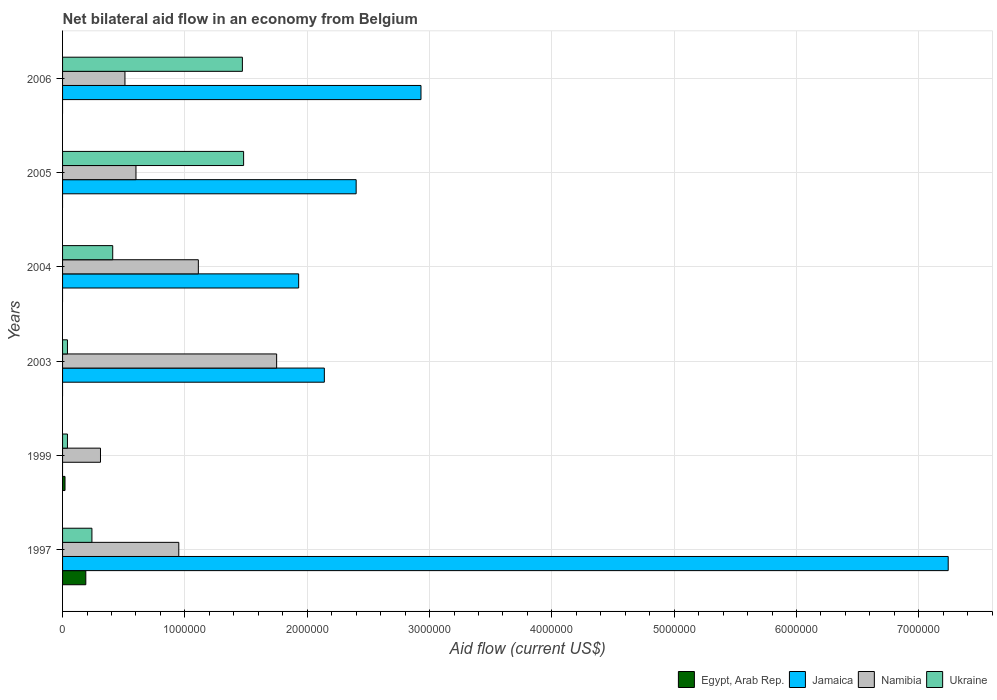How many different coloured bars are there?
Give a very brief answer. 4. Are the number of bars per tick equal to the number of legend labels?
Keep it short and to the point. No. Are the number of bars on each tick of the Y-axis equal?
Your response must be concise. No. What is the label of the 3rd group of bars from the top?
Provide a succinct answer. 2004. What is the net bilateral aid flow in Jamaica in 2005?
Make the answer very short. 2.40e+06. Across all years, what is the maximum net bilateral aid flow in Jamaica?
Your response must be concise. 7.24e+06. Across all years, what is the minimum net bilateral aid flow in Ukraine?
Offer a very short reply. 4.00e+04. In which year was the net bilateral aid flow in Jamaica maximum?
Make the answer very short. 1997. What is the total net bilateral aid flow in Egypt, Arab Rep. in the graph?
Offer a very short reply. 2.10e+05. What is the difference between the net bilateral aid flow in Jamaica in 2006 and the net bilateral aid flow in Egypt, Arab Rep. in 1997?
Your answer should be compact. 2.74e+06. What is the average net bilateral aid flow in Egypt, Arab Rep. per year?
Give a very brief answer. 3.50e+04. In the year 2005, what is the difference between the net bilateral aid flow in Namibia and net bilateral aid flow in Jamaica?
Your answer should be compact. -1.80e+06. In how many years, is the net bilateral aid flow in Namibia greater than 6200000 US$?
Your answer should be compact. 0. What is the ratio of the net bilateral aid flow in Ukraine in 2003 to that in 2006?
Make the answer very short. 0.03. Is the difference between the net bilateral aid flow in Namibia in 2003 and 2004 greater than the difference between the net bilateral aid flow in Jamaica in 2003 and 2004?
Keep it short and to the point. Yes. What is the difference between the highest and the second highest net bilateral aid flow in Ukraine?
Offer a terse response. 10000. What is the difference between the highest and the lowest net bilateral aid flow in Namibia?
Keep it short and to the point. 1.44e+06. Is the sum of the net bilateral aid flow in Jamaica in 2003 and 2004 greater than the maximum net bilateral aid flow in Egypt, Arab Rep. across all years?
Your answer should be very brief. Yes. Is it the case that in every year, the sum of the net bilateral aid flow in Namibia and net bilateral aid flow in Jamaica is greater than the sum of net bilateral aid flow in Egypt, Arab Rep. and net bilateral aid flow in Ukraine?
Your answer should be very brief. No. Are all the bars in the graph horizontal?
Your answer should be compact. Yes. What is the difference between two consecutive major ticks on the X-axis?
Offer a very short reply. 1.00e+06. Does the graph contain any zero values?
Give a very brief answer. Yes. Where does the legend appear in the graph?
Your answer should be compact. Bottom right. How many legend labels are there?
Provide a succinct answer. 4. What is the title of the graph?
Ensure brevity in your answer.  Net bilateral aid flow in an economy from Belgium. What is the label or title of the Y-axis?
Your response must be concise. Years. What is the Aid flow (current US$) of Egypt, Arab Rep. in 1997?
Your answer should be very brief. 1.90e+05. What is the Aid flow (current US$) of Jamaica in 1997?
Keep it short and to the point. 7.24e+06. What is the Aid flow (current US$) of Namibia in 1997?
Offer a terse response. 9.50e+05. What is the Aid flow (current US$) in Egypt, Arab Rep. in 1999?
Ensure brevity in your answer.  2.00e+04. What is the Aid flow (current US$) of Jamaica in 1999?
Make the answer very short. 0. What is the Aid flow (current US$) of Ukraine in 1999?
Offer a very short reply. 4.00e+04. What is the Aid flow (current US$) of Egypt, Arab Rep. in 2003?
Your answer should be compact. 0. What is the Aid flow (current US$) of Jamaica in 2003?
Offer a terse response. 2.14e+06. What is the Aid flow (current US$) in Namibia in 2003?
Make the answer very short. 1.75e+06. What is the Aid flow (current US$) of Ukraine in 2003?
Offer a terse response. 4.00e+04. What is the Aid flow (current US$) of Egypt, Arab Rep. in 2004?
Your answer should be compact. 0. What is the Aid flow (current US$) of Jamaica in 2004?
Your response must be concise. 1.93e+06. What is the Aid flow (current US$) in Namibia in 2004?
Your response must be concise. 1.11e+06. What is the Aid flow (current US$) of Jamaica in 2005?
Keep it short and to the point. 2.40e+06. What is the Aid flow (current US$) of Ukraine in 2005?
Your response must be concise. 1.48e+06. What is the Aid flow (current US$) in Egypt, Arab Rep. in 2006?
Your answer should be very brief. 0. What is the Aid flow (current US$) in Jamaica in 2006?
Give a very brief answer. 2.93e+06. What is the Aid flow (current US$) in Namibia in 2006?
Give a very brief answer. 5.10e+05. What is the Aid flow (current US$) in Ukraine in 2006?
Ensure brevity in your answer.  1.47e+06. Across all years, what is the maximum Aid flow (current US$) in Jamaica?
Offer a very short reply. 7.24e+06. Across all years, what is the maximum Aid flow (current US$) in Namibia?
Offer a very short reply. 1.75e+06. Across all years, what is the maximum Aid flow (current US$) of Ukraine?
Provide a short and direct response. 1.48e+06. Across all years, what is the minimum Aid flow (current US$) in Namibia?
Keep it short and to the point. 3.10e+05. What is the total Aid flow (current US$) in Jamaica in the graph?
Your answer should be very brief. 1.66e+07. What is the total Aid flow (current US$) in Namibia in the graph?
Your answer should be very brief. 5.23e+06. What is the total Aid flow (current US$) of Ukraine in the graph?
Offer a terse response. 3.68e+06. What is the difference between the Aid flow (current US$) in Namibia in 1997 and that in 1999?
Provide a succinct answer. 6.40e+05. What is the difference between the Aid flow (current US$) of Jamaica in 1997 and that in 2003?
Your response must be concise. 5.10e+06. What is the difference between the Aid flow (current US$) of Namibia in 1997 and that in 2003?
Keep it short and to the point. -8.00e+05. What is the difference between the Aid flow (current US$) in Jamaica in 1997 and that in 2004?
Provide a succinct answer. 5.31e+06. What is the difference between the Aid flow (current US$) in Namibia in 1997 and that in 2004?
Keep it short and to the point. -1.60e+05. What is the difference between the Aid flow (current US$) in Jamaica in 1997 and that in 2005?
Provide a succinct answer. 4.84e+06. What is the difference between the Aid flow (current US$) in Ukraine in 1997 and that in 2005?
Provide a short and direct response. -1.24e+06. What is the difference between the Aid flow (current US$) in Jamaica in 1997 and that in 2006?
Your response must be concise. 4.31e+06. What is the difference between the Aid flow (current US$) of Namibia in 1997 and that in 2006?
Ensure brevity in your answer.  4.40e+05. What is the difference between the Aid flow (current US$) of Ukraine in 1997 and that in 2006?
Your answer should be very brief. -1.23e+06. What is the difference between the Aid flow (current US$) of Namibia in 1999 and that in 2003?
Ensure brevity in your answer.  -1.44e+06. What is the difference between the Aid flow (current US$) of Namibia in 1999 and that in 2004?
Make the answer very short. -8.00e+05. What is the difference between the Aid flow (current US$) of Ukraine in 1999 and that in 2004?
Ensure brevity in your answer.  -3.70e+05. What is the difference between the Aid flow (current US$) in Namibia in 1999 and that in 2005?
Offer a very short reply. -2.90e+05. What is the difference between the Aid flow (current US$) in Ukraine in 1999 and that in 2005?
Keep it short and to the point. -1.44e+06. What is the difference between the Aid flow (current US$) in Namibia in 1999 and that in 2006?
Provide a succinct answer. -2.00e+05. What is the difference between the Aid flow (current US$) in Ukraine in 1999 and that in 2006?
Provide a short and direct response. -1.43e+06. What is the difference between the Aid flow (current US$) in Namibia in 2003 and that in 2004?
Your answer should be very brief. 6.40e+05. What is the difference between the Aid flow (current US$) in Ukraine in 2003 and that in 2004?
Provide a succinct answer. -3.70e+05. What is the difference between the Aid flow (current US$) of Namibia in 2003 and that in 2005?
Offer a terse response. 1.15e+06. What is the difference between the Aid flow (current US$) in Ukraine in 2003 and that in 2005?
Keep it short and to the point. -1.44e+06. What is the difference between the Aid flow (current US$) of Jamaica in 2003 and that in 2006?
Keep it short and to the point. -7.90e+05. What is the difference between the Aid flow (current US$) of Namibia in 2003 and that in 2006?
Your answer should be very brief. 1.24e+06. What is the difference between the Aid flow (current US$) of Ukraine in 2003 and that in 2006?
Your answer should be very brief. -1.43e+06. What is the difference between the Aid flow (current US$) in Jamaica in 2004 and that in 2005?
Keep it short and to the point. -4.70e+05. What is the difference between the Aid flow (current US$) in Namibia in 2004 and that in 2005?
Keep it short and to the point. 5.10e+05. What is the difference between the Aid flow (current US$) in Ukraine in 2004 and that in 2005?
Ensure brevity in your answer.  -1.07e+06. What is the difference between the Aid flow (current US$) of Ukraine in 2004 and that in 2006?
Offer a terse response. -1.06e+06. What is the difference between the Aid flow (current US$) of Jamaica in 2005 and that in 2006?
Your answer should be compact. -5.30e+05. What is the difference between the Aid flow (current US$) of Ukraine in 2005 and that in 2006?
Keep it short and to the point. 10000. What is the difference between the Aid flow (current US$) of Egypt, Arab Rep. in 1997 and the Aid flow (current US$) of Namibia in 1999?
Your answer should be very brief. -1.20e+05. What is the difference between the Aid flow (current US$) of Egypt, Arab Rep. in 1997 and the Aid flow (current US$) of Ukraine in 1999?
Offer a terse response. 1.50e+05. What is the difference between the Aid flow (current US$) in Jamaica in 1997 and the Aid flow (current US$) in Namibia in 1999?
Give a very brief answer. 6.93e+06. What is the difference between the Aid flow (current US$) in Jamaica in 1997 and the Aid flow (current US$) in Ukraine in 1999?
Provide a succinct answer. 7.20e+06. What is the difference between the Aid flow (current US$) of Namibia in 1997 and the Aid flow (current US$) of Ukraine in 1999?
Ensure brevity in your answer.  9.10e+05. What is the difference between the Aid flow (current US$) of Egypt, Arab Rep. in 1997 and the Aid flow (current US$) of Jamaica in 2003?
Offer a very short reply. -1.95e+06. What is the difference between the Aid flow (current US$) in Egypt, Arab Rep. in 1997 and the Aid flow (current US$) in Namibia in 2003?
Provide a short and direct response. -1.56e+06. What is the difference between the Aid flow (current US$) of Egypt, Arab Rep. in 1997 and the Aid flow (current US$) of Ukraine in 2003?
Offer a terse response. 1.50e+05. What is the difference between the Aid flow (current US$) in Jamaica in 1997 and the Aid flow (current US$) in Namibia in 2003?
Provide a succinct answer. 5.49e+06. What is the difference between the Aid flow (current US$) in Jamaica in 1997 and the Aid flow (current US$) in Ukraine in 2003?
Your response must be concise. 7.20e+06. What is the difference between the Aid flow (current US$) in Namibia in 1997 and the Aid flow (current US$) in Ukraine in 2003?
Keep it short and to the point. 9.10e+05. What is the difference between the Aid flow (current US$) of Egypt, Arab Rep. in 1997 and the Aid flow (current US$) of Jamaica in 2004?
Keep it short and to the point. -1.74e+06. What is the difference between the Aid flow (current US$) of Egypt, Arab Rep. in 1997 and the Aid flow (current US$) of Namibia in 2004?
Your answer should be compact. -9.20e+05. What is the difference between the Aid flow (current US$) in Jamaica in 1997 and the Aid flow (current US$) in Namibia in 2004?
Give a very brief answer. 6.13e+06. What is the difference between the Aid flow (current US$) of Jamaica in 1997 and the Aid flow (current US$) of Ukraine in 2004?
Your response must be concise. 6.83e+06. What is the difference between the Aid flow (current US$) in Namibia in 1997 and the Aid flow (current US$) in Ukraine in 2004?
Offer a very short reply. 5.40e+05. What is the difference between the Aid flow (current US$) of Egypt, Arab Rep. in 1997 and the Aid flow (current US$) of Jamaica in 2005?
Your response must be concise. -2.21e+06. What is the difference between the Aid flow (current US$) of Egypt, Arab Rep. in 1997 and the Aid flow (current US$) of Namibia in 2005?
Offer a terse response. -4.10e+05. What is the difference between the Aid flow (current US$) in Egypt, Arab Rep. in 1997 and the Aid flow (current US$) in Ukraine in 2005?
Your response must be concise. -1.29e+06. What is the difference between the Aid flow (current US$) of Jamaica in 1997 and the Aid flow (current US$) of Namibia in 2005?
Ensure brevity in your answer.  6.64e+06. What is the difference between the Aid flow (current US$) in Jamaica in 1997 and the Aid flow (current US$) in Ukraine in 2005?
Make the answer very short. 5.76e+06. What is the difference between the Aid flow (current US$) in Namibia in 1997 and the Aid flow (current US$) in Ukraine in 2005?
Your answer should be very brief. -5.30e+05. What is the difference between the Aid flow (current US$) in Egypt, Arab Rep. in 1997 and the Aid flow (current US$) in Jamaica in 2006?
Make the answer very short. -2.74e+06. What is the difference between the Aid flow (current US$) in Egypt, Arab Rep. in 1997 and the Aid flow (current US$) in Namibia in 2006?
Keep it short and to the point. -3.20e+05. What is the difference between the Aid flow (current US$) in Egypt, Arab Rep. in 1997 and the Aid flow (current US$) in Ukraine in 2006?
Give a very brief answer. -1.28e+06. What is the difference between the Aid flow (current US$) in Jamaica in 1997 and the Aid flow (current US$) in Namibia in 2006?
Offer a very short reply. 6.73e+06. What is the difference between the Aid flow (current US$) in Jamaica in 1997 and the Aid flow (current US$) in Ukraine in 2006?
Provide a succinct answer. 5.77e+06. What is the difference between the Aid flow (current US$) of Namibia in 1997 and the Aid flow (current US$) of Ukraine in 2006?
Your answer should be very brief. -5.20e+05. What is the difference between the Aid flow (current US$) of Egypt, Arab Rep. in 1999 and the Aid flow (current US$) of Jamaica in 2003?
Give a very brief answer. -2.12e+06. What is the difference between the Aid flow (current US$) of Egypt, Arab Rep. in 1999 and the Aid flow (current US$) of Namibia in 2003?
Give a very brief answer. -1.73e+06. What is the difference between the Aid flow (current US$) of Namibia in 1999 and the Aid flow (current US$) of Ukraine in 2003?
Provide a succinct answer. 2.70e+05. What is the difference between the Aid flow (current US$) in Egypt, Arab Rep. in 1999 and the Aid flow (current US$) in Jamaica in 2004?
Your answer should be very brief. -1.91e+06. What is the difference between the Aid flow (current US$) of Egypt, Arab Rep. in 1999 and the Aid flow (current US$) of Namibia in 2004?
Ensure brevity in your answer.  -1.09e+06. What is the difference between the Aid flow (current US$) of Egypt, Arab Rep. in 1999 and the Aid flow (current US$) of Ukraine in 2004?
Your answer should be very brief. -3.90e+05. What is the difference between the Aid flow (current US$) in Egypt, Arab Rep. in 1999 and the Aid flow (current US$) in Jamaica in 2005?
Offer a very short reply. -2.38e+06. What is the difference between the Aid flow (current US$) of Egypt, Arab Rep. in 1999 and the Aid flow (current US$) of Namibia in 2005?
Your response must be concise. -5.80e+05. What is the difference between the Aid flow (current US$) of Egypt, Arab Rep. in 1999 and the Aid flow (current US$) of Ukraine in 2005?
Your answer should be compact. -1.46e+06. What is the difference between the Aid flow (current US$) of Namibia in 1999 and the Aid flow (current US$) of Ukraine in 2005?
Make the answer very short. -1.17e+06. What is the difference between the Aid flow (current US$) in Egypt, Arab Rep. in 1999 and the Aid flow (current US$) in Jamaica in 2006?
Offer a terse response. -2.91e+06. What is the difference between the Aid flow (current US$) in Egypt, Arab Rep. in 1999 and the Aid flow (current US$) in Namibia in 2006?
Provide a succinct answer. -4.90e+05. What is the difference between the Aid flow (current US$) of Egypt, Arab Rep. in 1999 and the Aid flow (current US$) of Ukraine in 2006?
Your answer should be compact. -1.45e+06. What is the difference between the Aid flow (current US$) of Namibia in 1999 and the Aid flow (current US$) of Ukraine in 2006?
Your response must be concise. -1.16e+06. What is the difference between the Aid flow (current US$) of Jamaica in 2003 and the Aid flow (current US$) of Namibia in 2004?
Keep it short and to the point. 1.03e+06. What is the difference between the Aid flow (current US$) of Jamaica in 2003 and the Aid flow (current US$) of Ukraine in 2004?
Offer a terse response. 1.73e+06. What is the difference between the Aid flow (current US$) of Namibia in 2003 and the Aid flow (current US$) of Ukraine in 2004?
Provide a succinct answer. 1.34e+06. What is the difference between the Aid flow (current US$) in Jamaica in 2003 and the Aid flow (current US$) in Namibia in 2005?
Make the answer very short. 1.54e+06. What is the difference between the Aid flow (current US$) of Namibia in 2003 and the Aid flow (current US$) of Ukraine in 2005?
Your answer should be compact. 2.70e+05. What is the difference between the Aid flow (current US$) in Jamaica in 2003 and the Aid flow (current US$) in Namibia in 2006?
Offer a very short reply. 1.63e+06. What is the difference between the Aid flow (current US$) in Jamaica in 2003 and the Aid flow (current US$) in Ukraine in 2006?
Keep it short and to the point. 6.70e+05. What is the difference between the Aid flow (current US$) of Namibia in 2003 and the Aid flow (current US$) of Ukraine in 2006?
Your answer should be very brief. 2.80e+05. What is the difference between the Aid flow (current US$) in Jamaica in 2004 and the Aid flow (current US$) in Namibia in 2005?
Provide a short and direct response. 1.33e+06. What is the difference between the Aid flow (current US$) of Namibia in 2004 and the Aid flow (current US$) of Ukraine in 2005?
Give a very brief answer. -3.70e+05. What is the difference between the Aid flow (current US$) in Jamaica in 2004 and the Aid flow (current US$) in Namibia in 2006?
Give a very brief answer. 1.42e+06. What is the difference between the Aid flow (current US$) in Namibia in 2004 and the Aid flow (current US$) in Ukraine in 2006?
Your answer should be compact. -3.60e+05. What is the difference between the Aid flow (current US$) of Jamaica in 2005 and the Aid flow (current US$) of Namibia in 2006?
Ensure brevity in your answer.  1.89e+06. What is the difference between the Aid flow (current US$) of Jamaica in 2005 and the Aid flow (current US$) of Ukraine in 2006?
Offer a very short reply. 9.30e+05. What is the difference between the Aid flow (current US$) in Namibia in 2005 and the Aid flow (current US$) in Ukraine in 2006?
Your answer should be very brief. -8.70e+05. What is the average Aid flow (current US$) of Egypt, Arab Rep. per year?
Keep it short and to the point. 3.50e+04. What is the average Aid flow (current US$) in Jamaica per year?
Provide a short and direct response. 2.77e+06. What is the average Aid flow (current US$) in Namibia per year?
Ensure brevity in your answer.  8.72e+05. What is the average Aid flow (current US$) of Ukraine per year?
Provide a succinct answer. 6.13e+05. In the year 1997, what is the difference between the Aid flow (current US$) in Egypt, Arab Rep. and Aid flow (current US$) in Jamaica?
Offer a very short reply. -7.05e+06. In the year 1997, what is the difference between the Aid flow (current US$) in Egypt, Arab Rep. and Aid flow (current US$) in Namibia?
Give a very brief answer. -7.60e+05. In the year 1997, what is the difference between the Aid flow (current US$) in Jamaica and Aid flow (current US$) in Namibia?
Make the answer very short. 6.29e+06. In the year 1997, what is the difference between the Aid flow (current US$) of Namibia and Aid flow (current US$) of Ukraine?
Make the answer very short. 7.10e+05. In the year 1999, what is the difference between the Aid flow (current US$) of Namibia and Aid flow (current US$) of Ukraine?
Offer a very short reply. 2.70e+05. In the year 2003, what is the difference between the Aid flow (current US$) of Jamaica and Aid flow (current US$) of Namibia?
Make the answer very short. 3.90e+05. In the year 2003, what is the difference between the Aid flow (current US$) of Jamaica and Aid flow (current US$) of Ukraine?
Offer a terse response. 2.10e+06. In the year 2003, what is the difference between the Aid flow (current US$) in Namibia and Aid flow (current US$) in Ukraine?
Provide a succinct answer. 1.71e+06. In the year 2004, what is the difference between the Aid flow (current US$) in Jamaica and Aid flow (current US$) in Namibia?
Provide a short and direct response. 8.20e+05. In the year 2004, what is the difference between the Aid flow (current US$) in Jamaica and Aid flow (current US$) in Ukraine?
Provide a succinct answer. 1.52e+06. In the year 2004, what is the difference between the Aid flow (current US$) in Namibia and Aid flow (current US$) in Ukraine?
Ensure brevity in your answer.  7.00e+05. In the year 2005, what is the difference between the Aid flow (current US$) of Jamaica and Aid flow (current US$) of Namibia?
Offer a terse response. 1.80e+06. In the year 2005, what is the difference between the Aid flow (current US$) in Jamaica and Aid flow (current US$) in Ukraine?
Your answer should be very brief. 9.20e+05. In the year 2005, what is the difference between the Aid flow (current US$) of Namibia and Aid flow (current US$) of Ukraine?
Your response must be concise. -8.80e+05. In the year 2006, what is the difference between the Aid flow (current US$) of Jamaica and Aid flow (current US$) of Namibia?
Give a very brief answer. 2.42e+06. In the year 2006, what is the difference between the Aid flow (current US$) of Jamaica and Aid flow (current US$) of Ukraine?
Make the answer very short. 1.46e+06. In the year 2006, what is the difference between the Aid flow (current US$) in Namibia and Aid flow (current US$) in Ukraine?
Your answer should be very brief. -9.60e+05. What is the ratio of the Aid flow (current US$) in Egypt, Arab Rep. in 1997 to that in 1999?
Provide a short and direct response. 9.5. What is the ratio of the Aid flow (current US$) in Namibia in 1997 to that in 1999?
Give a very brief answer. 3.06. What is the ratio of the Aid flow (current US$) of Jamaica in 1997 to that in 2003?
Your answer should be very brief. 3.38. What is the ratio of the Aid flow (current US$) in Namibia in 1997 to that in 2003?
Make the answer very short. 0.54. What is the ratio of the Aid flow (current US$) in Ukraine in 1997 to that in 2003?
Offer a very short reply. 6. What is the ratio of the Aid flow (current US$) in Jamaica in 1997 to that in 2004?
Provide a succinct answer. 3.75. What is the ratio of the Aid flow (current US$) in Namibia in 1997 to that in 2004?
Ensure brevity in your answer.  0.86. What is the ratio of the Aid flow (current US$) of Ukraine in 1997 to that in 2004?
Your answer should be compact. 0.59. What is the ratio of the Aid flow (current US$) in Jamaica in 1997 to that in 2005?
Keep it short and to the point. 3.02. What is the ratio of the Aid flow (current US$) of Namibia in 1997 to that in 2005?
Offer a terse response. 1.58. What is the ratio of the Aid flow (current US$) in Ukraine in 1997 to that in 2005?
Keep it short and to the point. 0.16. What is the ratio of the Aid flow (current US$) of Jamaica in 1997 to that in 2006?
Offer a very short reply. 2.47. What is the ratio of the Aid flow (current US$) in Namibia in 1997 to that in 2006?
Provide a short and direct response. 1.86. What is the ratio of the Aid flow (current US$) in Ukraine in 1997 to that in 2006?
Offer a terse response. 0.16. What is the ratio of the Aid flow (current US$) of Namibia in 1999 to that in 2003?
Offer a very short reply. 0.18. What is the ratio of the Aid flow (current US$) of Ukraine in 1999 to that in 2003?
Provide a short and direct response. 1. What is the ratio of the Aid flow (current US$) of Namibia in 1999 to that in 2004?
Keep it short and to the point. 0.28. What is the ratio of the Aid flow (current US$) in Ukraine in 1999 to that in 2004?
Your answer should be very brief. 0.1. What is the ratio of the Aid flow (current US$) of Namibia in 1999 to that in 2005?
Make the answer very short. 0.52. What is the ratio of the Aid flow (current US$) of Ukraine in 1999 to that in 2005?
Ensure brevity in your answer.  0.03. What is the ratio of the Aid flow (current US$) of Namibia in 1999 to that in 2006?
Ensure brevity in your answer.  0.61. What is the ratio of the Aid flow (current US$) of Ukraine in 1999 to that in 2006?
Keep it short and to the point. 0.03. What is the ratio of the Aid flow (current US$) in Jamaica in 2003 to that in 2004?
Ensure brevity in your answer.  1.11. What is the ratio of the Aid flow (current US$) of Namibia in 2003 to that in 2004?
Provide a short and direct response. 1.58. What is the ratio of the Aid flow (current US$) in Ukraine in 2003 to that in 2004?
Make the answer very short. 0.1. What is the ratio of the Aid flow (current US$) of Jamaica in 2003 to that in 2005?
Keep it short and to the point. 0.89. What is the ratio of the Aid flow (current US$) of Namibia in 2003 to that in 2005?
Your answer should be very brief. 2.92. What is the ratio of the Aid flow (current US$) of Ukraine in 2003 to that in 2005?
Give a very brief answer. 0.03. What is the ratio of the Aid flow (current US$) in Jamaica in 2003 to that in 2006?
Ensure brevity in your answer.  0.73. What is the ratio of the Aid flow (current US$) in Namibia in 2003 to that in 2006?
Your answer should be compact. 3.43. What is the ratio of the Aid flow (current US$) of Ukraine in 2003 to that in 2006?
Offer a terse response. 0.03. What is the ratio of the Aid flow (current US$) in Jamaica in 2004 to that in 2005?
Make the answer very short. 0.8. What is the ratio of the Aid flow (current US$) in Namibia in 2004 to that in 2005?
Provide a short and direct response. 1.85. What is the ratio of the Aid flow (current US$) in Ukraine in 2004 to that in 2005?
Provide a succinct answer. 0.28. What is the ratio of the Aid flow (current US$) of Jamaica in 2004 to that in 2006?
Your response must be concise. 0.66. What is the ratio of the Aid flow (current US$) in Namibia in 2004 to that in 2006?
Give a very brief answer. 2.18. What is the ratio of the Aid flow (current US$) of Ukraine in 2004 to that in 2006?
Keep it short and to the point. 0.28. What is the ratio of the Aid flow (current US$) in Jamaica in 2005 to that in 2006?
Ensure brevity in your answer.  0.82. What is the ratio of the Aid flow (current US$) in Namibia in 2005 to that in 2006?
Your response must be concise. 1.18. What is the ratio of the Aid flow (current US$) in Ukraine in 2005 to that in 2006?
Ensure brevity in your answer.  1.01. What is the difference between the highest and the second highest Aid flow (current US$) in Jamaica?
Offer a very short reply. 4.31e+06. What is the difference between the highest and the second highest Aid flow (current US$) in Namibia?
Make the answer very short. 6.40e+05. What is the difference between the highest and the second highest Aid flow (current US$) of Ukraine?
Keep it short and to the point. 10000. What is the difference between the highest and the lowest Aid flow (current US$) of Jamaica?
Make the answer very short. 7.24e+06. What is the difference between the highest and the lowest Aid flow (current US$) of Namibia?
Your answer should be very brief. 1.44e+06. What is the difference between the highest and the lowest Aid flow (current US$) in Ukraine?
Give a very brief answer. 1.44e+06. 